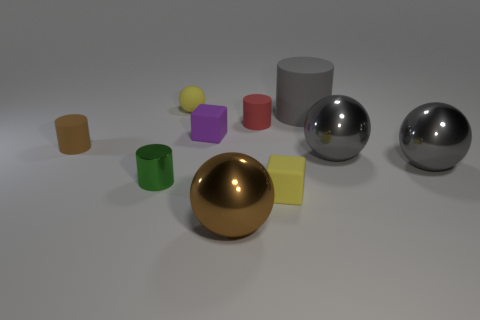Is there anything else that is the same shape as the small red thing?
Offer a terse response. Yes. What number of balls are either green things or big matte objects?
Give a very brief answer. 0. What is the shape of the purple thing?
Keep it short and to the point. Cube. Are there any tiny metal cylinders in front of the red object?
Provide a succinct answer. Yes. Are the brown ball and the cylinder in front of the tiny brown matte thing made of the same material?
Offer a terse response. Yes. There is a large gray thing that is behind the tiny red cylinder; is its shape the same as the green thing?
Your response must be concise. Yes. What number of objects have the same material as the gray cylinder?
Provide a succinct answer. 5. What number of things are matte objects that are in front of the tiny green shiny thing or cylinders?
Make the answer very short. 5. How big is the yellow ball?
Ensure brevity in your answer.  Small. There is a yellow object that is on the left side of the small rubber object right of the red cylinder; what is it made of?
Provide a succinct answer. Rubber. 